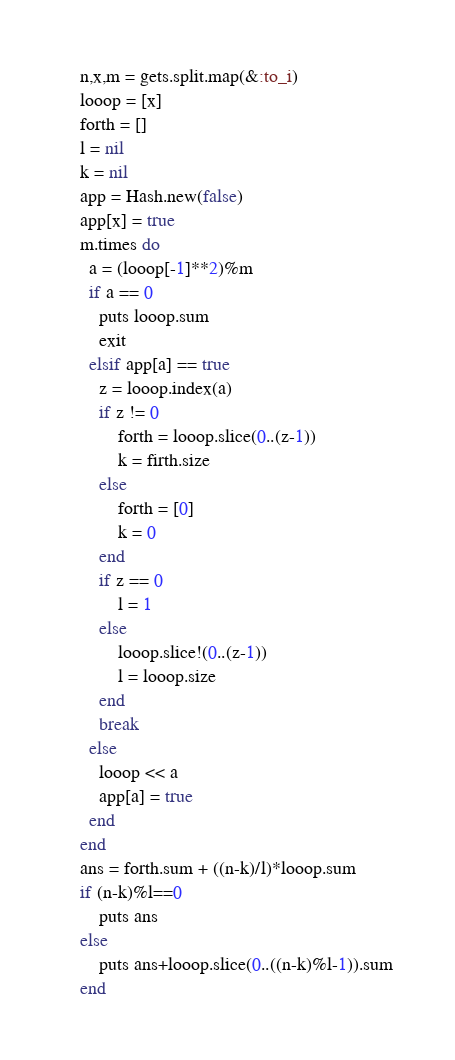Convert code to text. <code><loc_0><loc_0><loc_500><loc_500><_Ruby_>n,x,m = gets.split.map(&:to_i)
looop = [x]
forth = []
l = nil
k = nil
app = Hash.new(false)
app[x] = true
m.times do
  a = (looop[-1]**2)%m
  if a == 0
    puts looop.sum
    exit
  elsif app[a] == true
    z = looop.index(a)
    if z != 0
        forth = looop.slice(0..(z-1))
        k = firth.size
    else
        forth = [0]
        k = 0
    end
    if z == 0
        l = 1
    else
        looop.slice!(0..(z-1))
        l = looop.size
    end
    break
  else
    looop << a
    app[a] = true
  end
end
ans = forth.sum + ((n-k)/l)*looop.sum
if (n-k)%l==0
    puts ans
else
    puts ans+looop.slice(0..((n-k)%l-1)).sum
end
</code> 